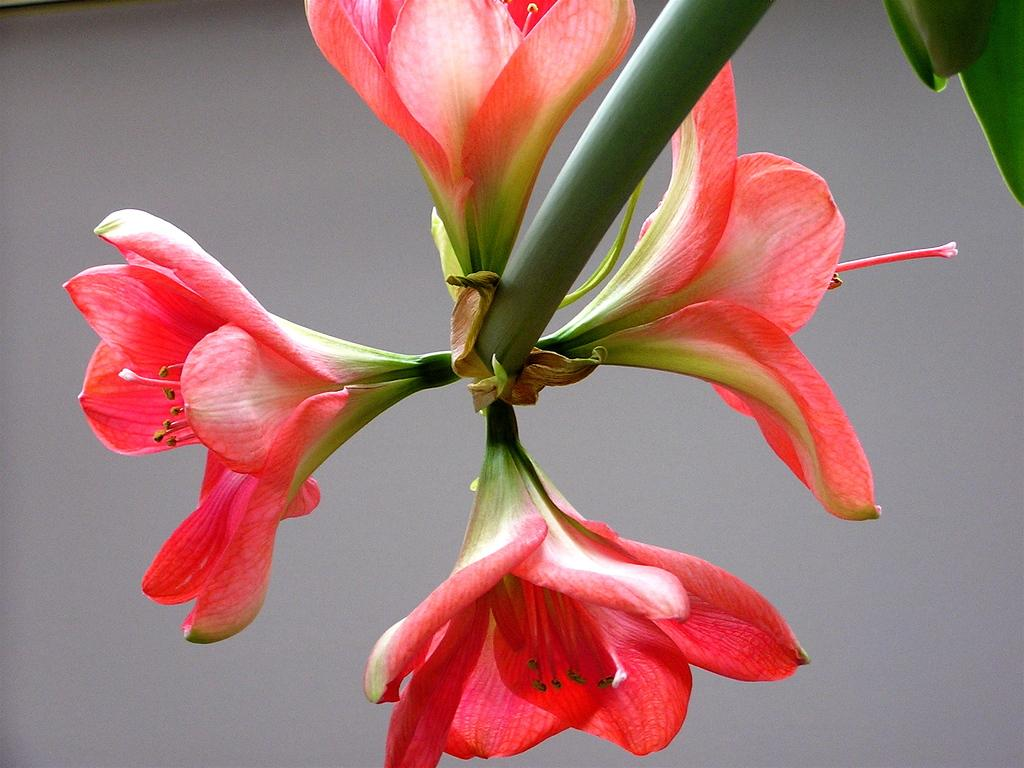What is the main subject of the image? There is a flower in the image. Where are the leaves located in the image? The leaves are in the top right corner of the image. What can be seen behind the flower and leaves in the image? The background is visible in the image. What type of humor is depicted in the title of the image? There is no title present in the image, so it is not possible to determine what type of humor might be depicted. 